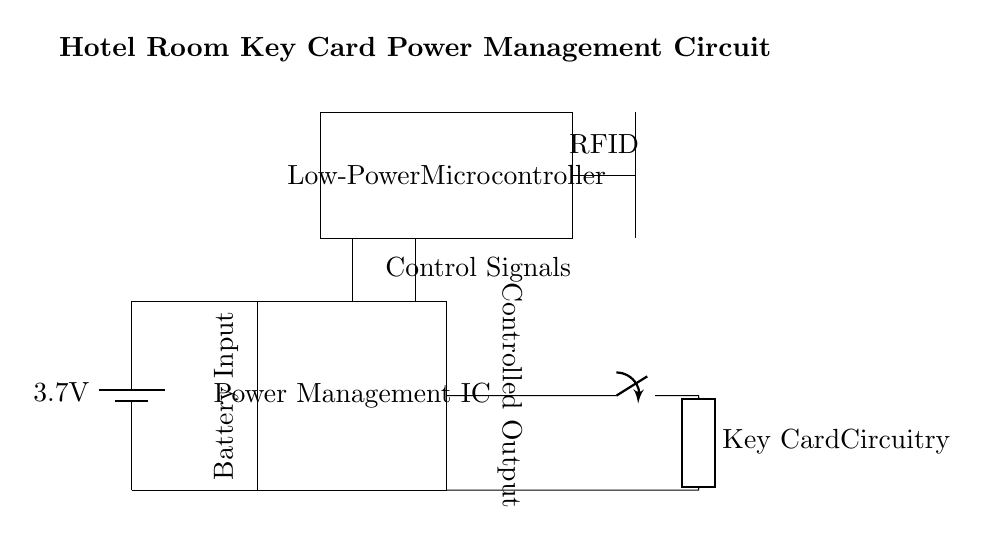What is the voltage of the battery? The battery in the diagram is labeled with a voltage of 3.7 volts, which indicates the potential difference it provides.
Answer: 3.7 volts What component manages power in this circuit? The Power Management IC box in the circuit diagram is specifically labeled, indicating that it is responsible for controlling the power distribution to other components.
Answer: Power Management IC How many components are connected to the battery? There are two drawn connections leading from the battery; one goes to the Power Management IC (input) and the other towards the ground (0V).
Answer: Two What is the function of the low-power microcontroller? The low-power microcontroller is labeled and positioned above the Power Management IC; it typically serves to manage and control other components, including responding to signals.
Answer: Control signals What type of antenna is shown in the diagram? The diagram features an RFID antenna, which is specifically marked and represents a component used for wireless communication.
Answer: RFID What happens to the output when the switch is open? The switch disconnects the output from the key card circuitry when in the open position, effectively preventing power from reaching that part of the circuit.
Answer: No power to key card How does the Power Management IC interact with the microcontroller? The Power Management IC provides controlled output power to the microcontroller based on its design; it ensures that the microcontroller operates efficiently while conserving battery life.
Answer: Efficient power distribution 